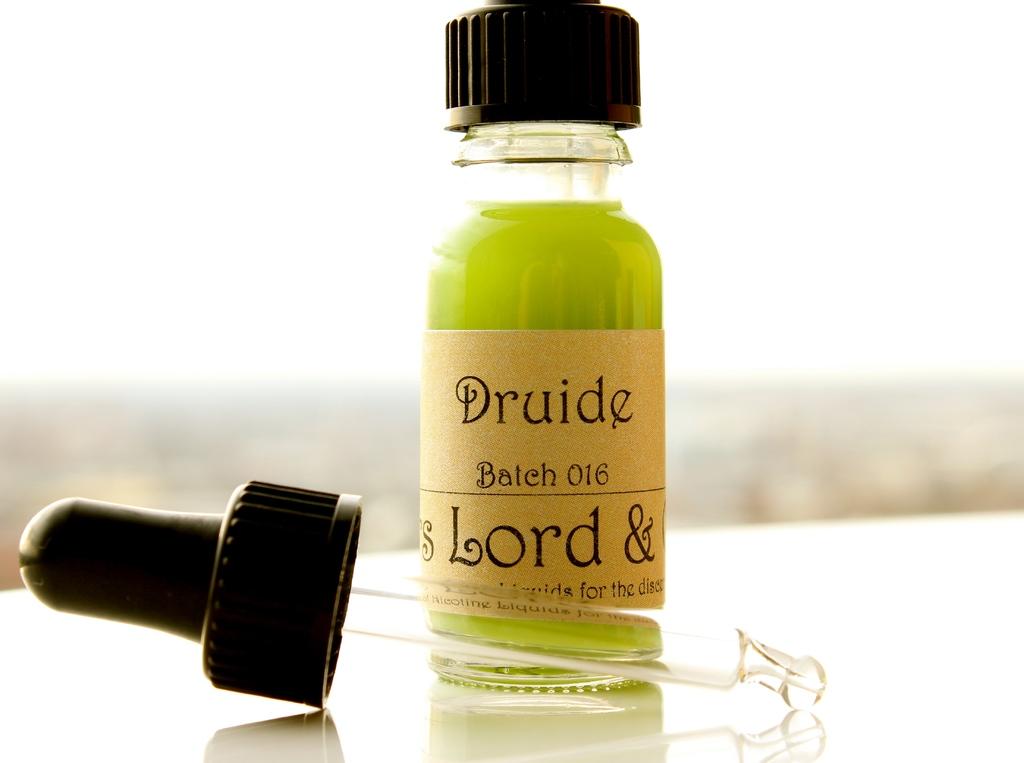What number batch is this liquid?
Offer a very short reply. 016. What brand can you see?
Your answer should be compact. Druide. 